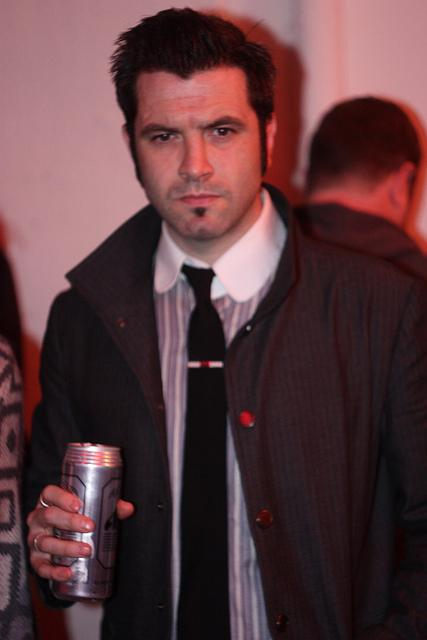How is the man holding the can feeling? Please explain your reasoning. angry. He's angry. 